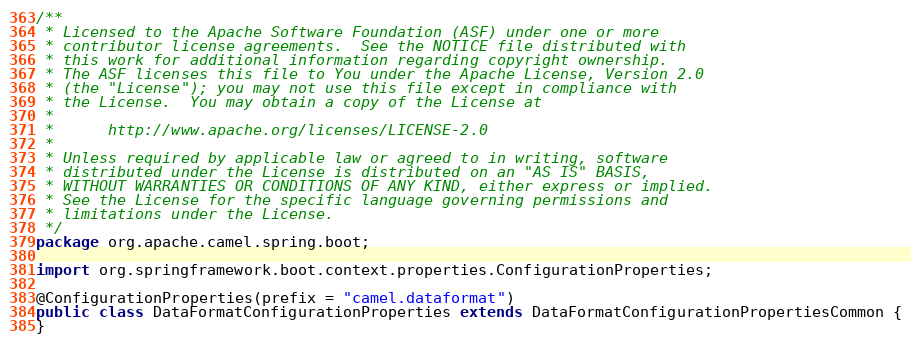Convert code to text. <code><loc_0><loc_0><loc_500><loc_500><_Java_>/**
 * Licensed to the Apache Software Foundation (ASF) under one or more
 * contributor license agreements.  See the NOTICE file distributed with
 * this work for additional information regarding copyright ownership.
 * The ASF licenses this file to You under the Apache License, Version 2.0
 * (the "License"); you may not use this file except in compliance with
 * the License.  You may obtain a copy of the License at
 *
 *      http://www.apache.org/licenses/LICENSE-2.0
 *
 * Unless required by applicable law or agreed to in writing, software
 * distributed under the License is distributed on an "AS IS" BASIS,
 * WITHOUT WARRANTIES OR CONDITIONS OF ANY KIND, either express or implied.
 * See the License for the specific language governing permissions and
 * limitations under the License.
 */
package org.apache.camel.spring.boot;

import org.springframework.boot.context.properties.ConfigurationProperties;

@ConfigurationProperties(prefix = "camel.dataformat")
public class DataFormatConfigurationProperties extends DataFormatConfigurationPropertiesCommon {
}
</code> 